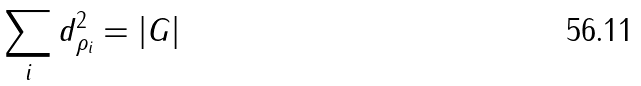Convert formula to latex. <formula><loc_0><loc_0><loc_500><loc_500>\sum _ { i } d _ { \rho _ { i } } ^ { 2 } = | G |</formula> 